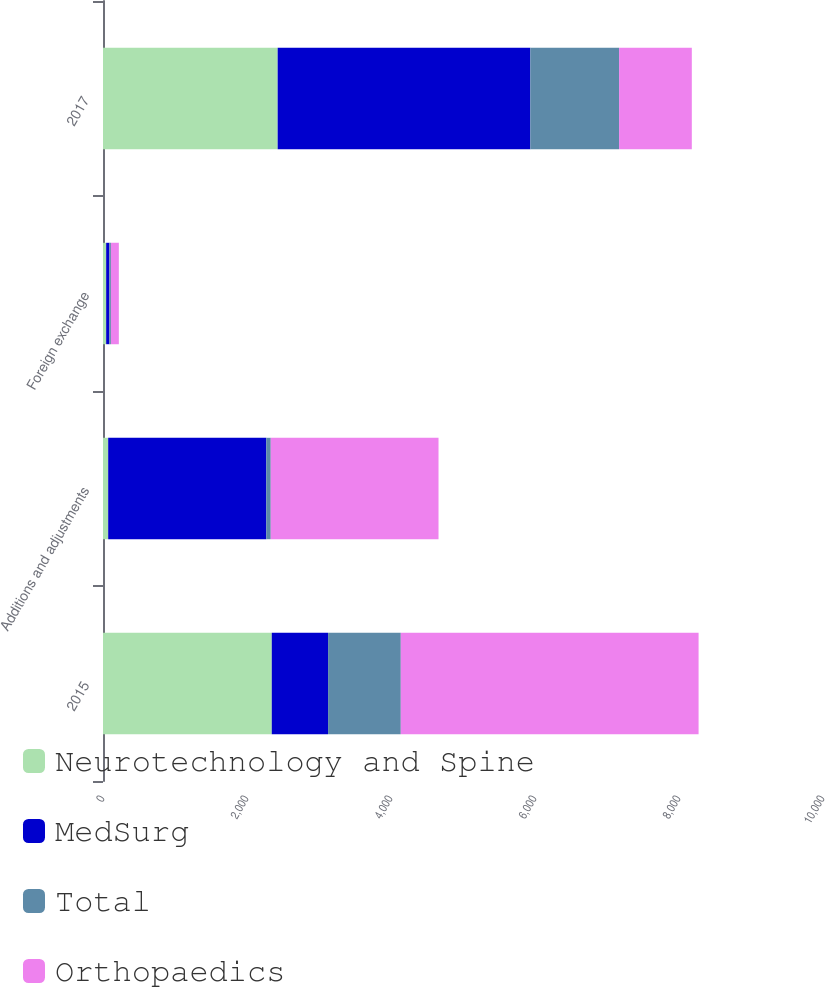Convert chart. <chart><loc_0><loc_0><loc_500><loc_500><stacked_bar_chart><ecel><fcel>2015<fcel>Additions and adjustments<fcel>Foreign exchange<fcel>2017<nl><fcel>Neurotechnology and Spine<fcel>2344<fcel>72<fcel>44<fcel>2426<nl><fcel>MedSurg<fcel>782<fcel>2196<fcel>44<fcel>3509<nl><fcel>Total<fcel>1010<fcel>62<fcel>22<fcel>1233<nl><fcel>Orthopaedics<fcel>4136<fcel>2330<fcel>110<fcel>1010<nl></chart> 